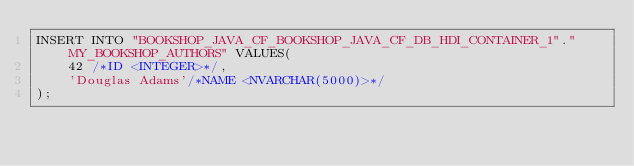<code> <loc_0><loc_0><loc_500><loc_500><_SQL_>INSERT INTO "BOOKSHOP_JAVA_CF_BOOKSHOP_JAVA_CF_DB_HDI_CONTAINER_1"."MY_BOOKSHOP_AUTHORS" VALUES(
	42 /*ID <INTEGER>*/,
	'Douglas Adams'/*NAME <NVARCHAR(5000)>*/
);</code> 